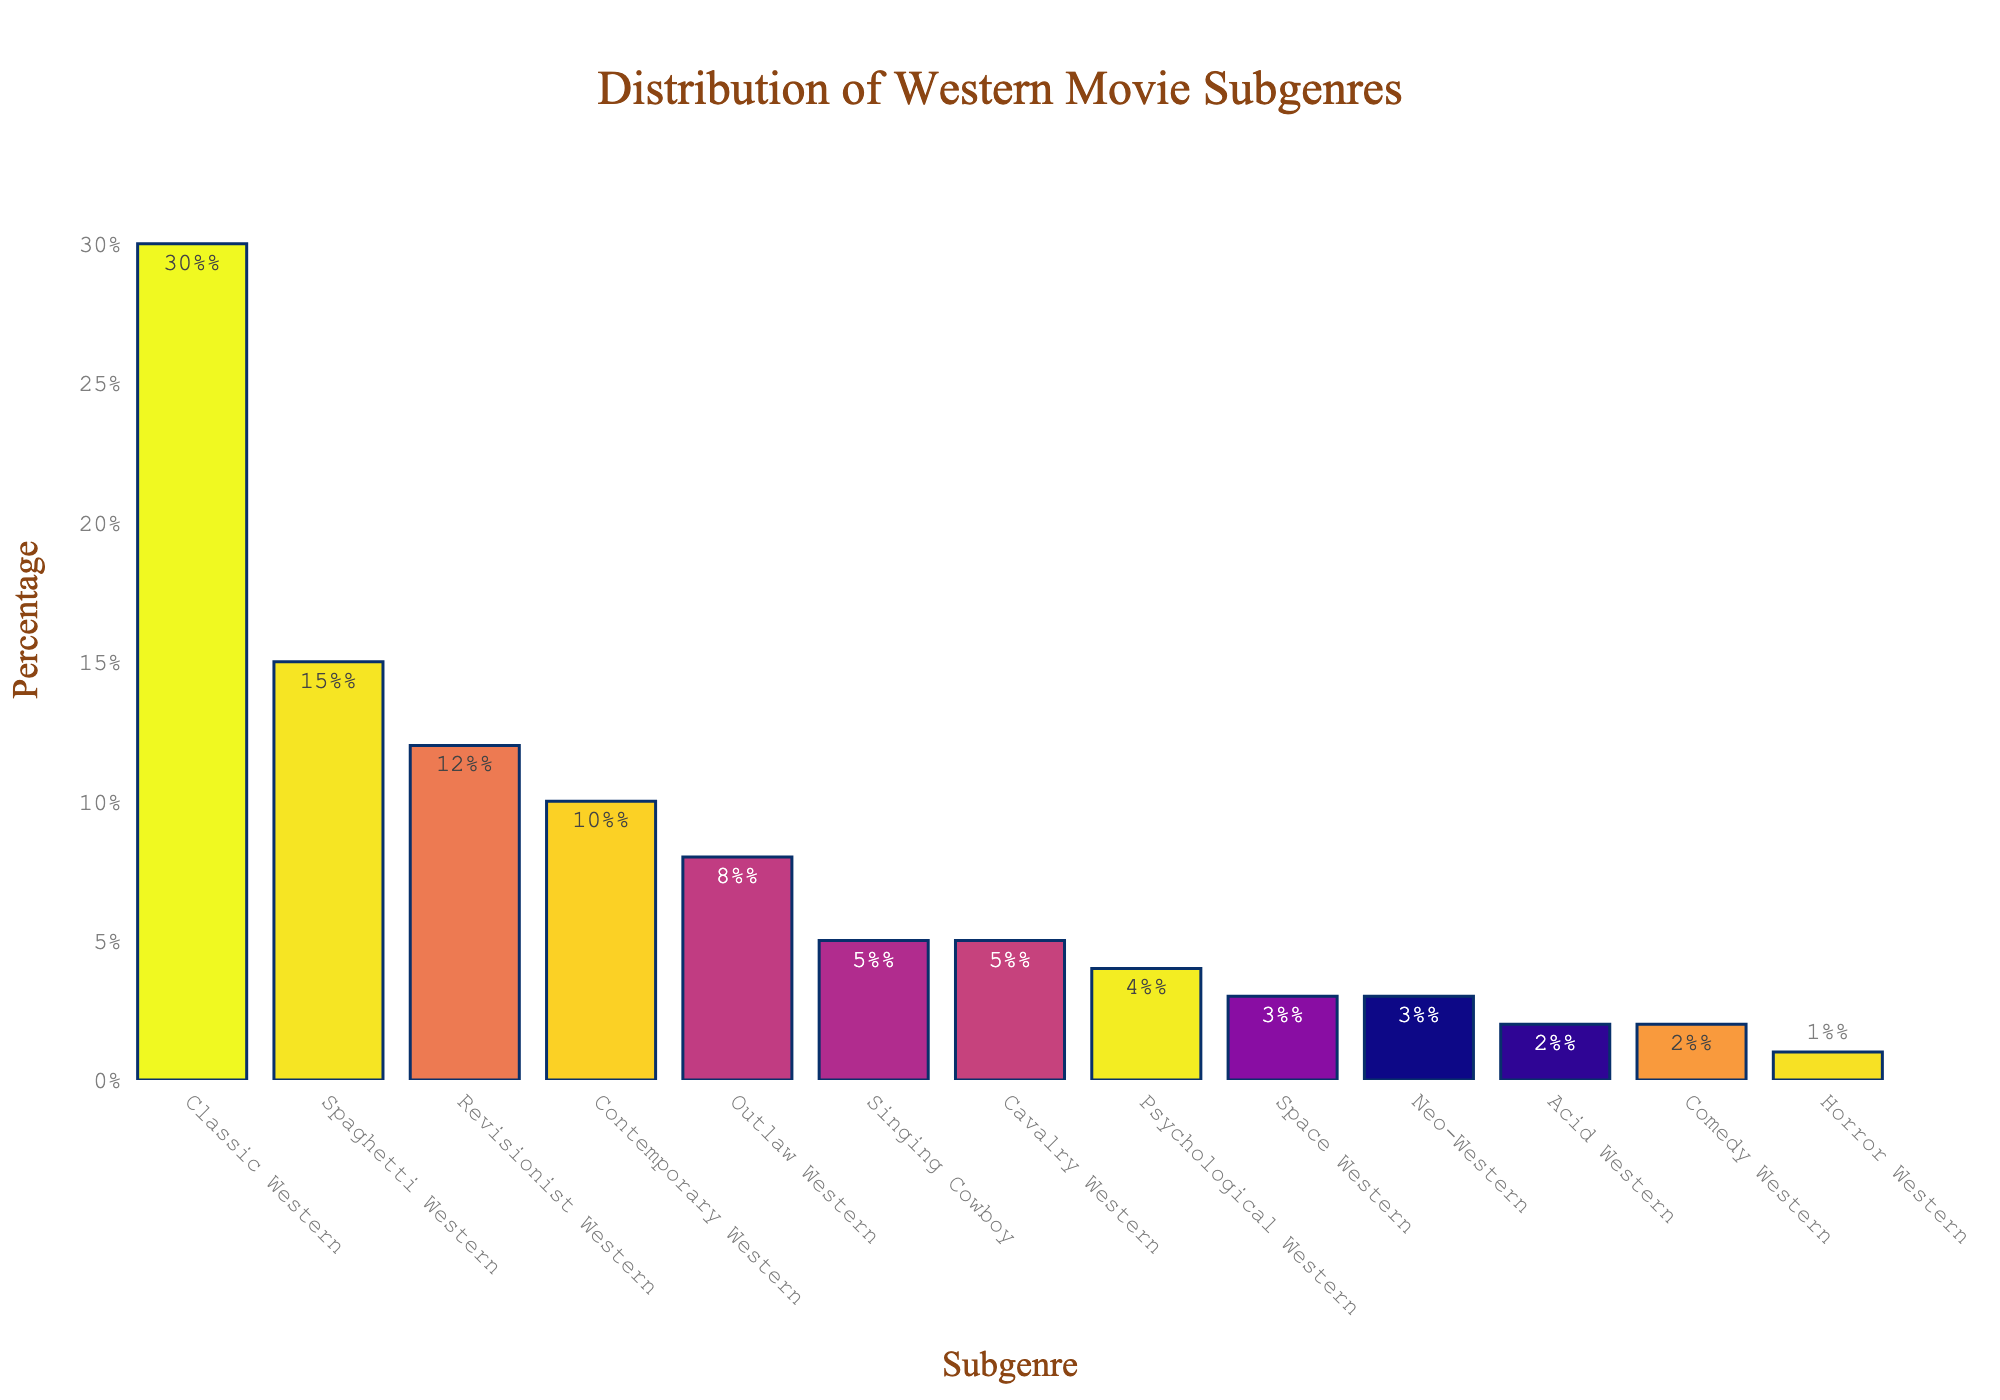Which subgenre has the highest percentage? The bar with the highest height represents the subgenre with the highest percentage. In this case, the "Classic Western" bar is the highest, indicating it has the highest percentage.
Answer: Classic Western How many subgenres have a percentage greater than 10%? Count the bars whose height corresponds to a percentage greater than 10%. The subgenres that meet this criteria are "Classic Western", "Spaghetti Western", "Revisionist Western", and "Contemporary Western". That's four subgenres.
Answer: 4 What is the combined percentage of "Singing Cowboy" and "Cavalry Western"? Locate the bars for "Singing Cowboy" and "Cavalry Western" and add their percentages together. Both have a percentage of 5%, so the combined percentage is 5% + 5% = 10%.
Answer: 10% Which subgenre has a lower percentage, "Neo-Western" or "Acid Western"? Compare the heights of the bars for "Neo-Western" and "Acid Western". "Neo-Western" has a percentage of 3%, while "Acid Western" has a percentage of 2%. So, "Acid Western" has a lower percentage.
Answer: Acid Western What is the total percentage of all subgenres labeled on the chart? Sum the percentages of all the bars shown in the chart. The total percentage is 30 + 15 + 12 + 10 + 8 + 5 + 5 + 4 + 3 + 3 + 2 + 2 + 1 = 100%.
Answer: 100% Which subgenres together contribute to exactly 50% of the total? Identify and sum up the percentages of the subgenres sequentially until the sum reaches 50%. "Classic Western" (30%) + "Spaghetti Western" (15%) + "Revisionist Western" (12%) = 57%, which exceeds 50%. Then, "Contemporary Western" (10%) + "Outlaw Western" (8%) + "Singing Cowboy" (5%) + "Cavalry Western" (5%) = 28%, to find the exact pairing, combine "Classic Western" (30%) + "Spaghetti Western" (15%) + "Outlaw Western" (8%) = 53% over, so "Classic Western" (30% + "Revisionist Western" (12%) + "Outlaw Western" (8%)=  30% + 12% + 8% = 50%.
Answer: Classic Western, Revisionist Western, Outlaw Western What is the median percentage of the subgenres? Arrange the percentages in ascending order and find the middle value. The ordered percentages are 1, 2, 2, 3, 3, 4, 5, 5, 8, 10, 12, 15, 30. With 13 values, the median is the 7th value, which is 5%.
Answer: 5% By how much does the percentage of "Classic Western" exceed the percentage of "Spaghetti Western"? Subtract the percentage of "Spaghetti Western" from "Classic Western". This is 30% - 15% = 15%.
Answer: 15% What is the average percentage of "Neo-Western", "Acid Western", and "Comedy Western"? Add the percentages of these subgenres and divide by the number of subgenres. The percentages are 3%, 2%, and 2%. So, (3% + 2% + 2%) / 3 = 7% / 3 = approximately 2.33%.
Answer: 2.33% Which subgenre has the third-highest percentage? Identify the subgenres with the largest, second-largest, and third-largest percentages. "Classic Western" is the highest (30%), "Spaghetti Western" is the second highest (15%), and "Revisionist Western" is the third-highest (12%).
Answer: Revisionist Western 